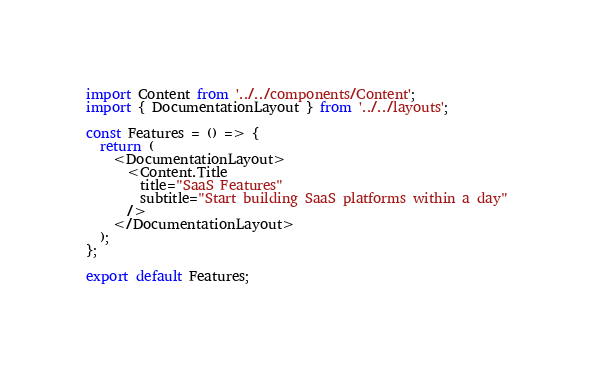Convert code to text. <code><loc_0><loc_0><loc_500><loc_500><_JavaScript_>import Content from '../../components/Content';
import { DocumentationLayout } from '../../layouts';

const Features = () => {
  return (
    <DocumentationLayout>
      <Content.Title
        title="SaaS Features"
        subtitle="Start building SaaS platforms within a day"
      />
    </DocumentationLayout>
  );
};

export default Features;
</code> 